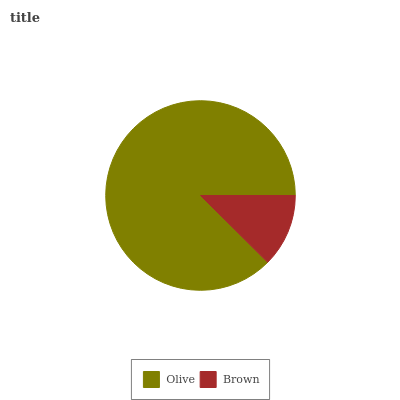Is Brown the minimum?
Answer yes or no. Yes. Is Olive the maximum?
Answer yes or no. Yes. Is Brown the maximum?
Answer yes or no. No. Is Olive greater than Brown?
Answer yes or no. Yes. Is Brown less than Olive?
Answer yes or no. Yes. Is Brown greater than Olive?
Answer yes or no. No. Is Olive less than Brown?
Answer yes or no. No. Is Olive the high median?
Answer yes or no. Yes. Is Brown the low median?
Answer yes or no. Yes. Is Brown the high median?
Answer yes or no. No. Is Olive the low median?
Answer yes or no. No. 